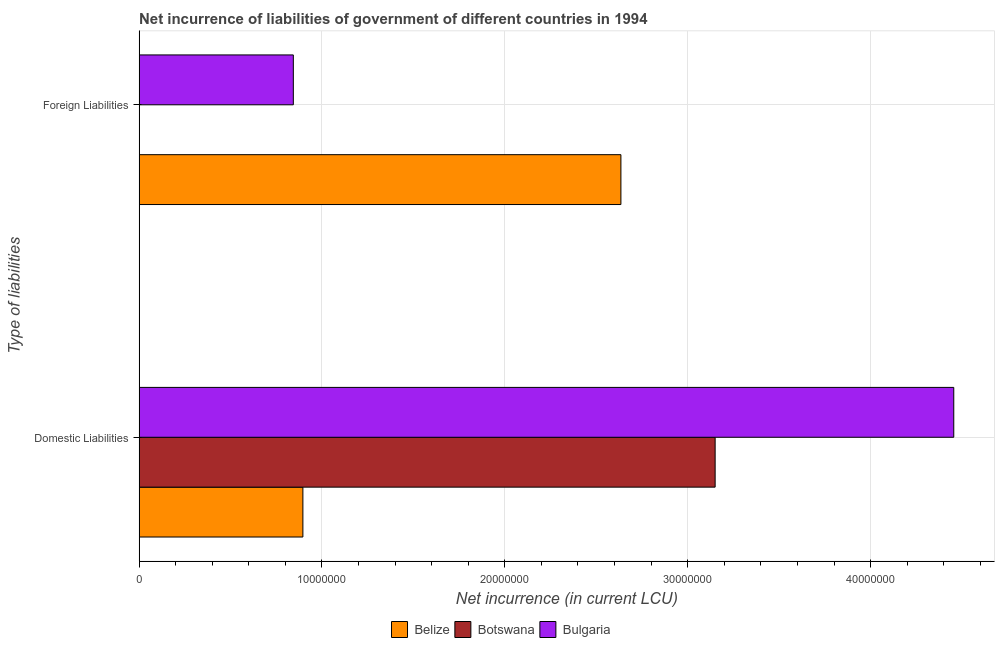How many different coloured bars are there?
Make the answer very short. 3. Are the number of bars per tick equal to the number of legend labels?
Your answer should be compact. No. How many bars are there on the 2nd tick from the bottom?
Your response must be concise. 2. What is the label of the 1st group of bars from the top?
Offer a very short reply. Foreign Liabilities. What is the net incurrence of domestic liabilities in Botswana?
Provide a succinct answer. 3.15e+07. Across all countries, what is the maximum net incurrence of domestic liabilities?
Ensure brevity in your answer.  4.45e+07. Across all countries, what is the minimum net incurrence of domestic liabilities?
Offer a very short reply. 8.96e+06. In which country was the net incurrence of foreign liabilities maximum?
Your answer should be compact. Belize. What is the total net incurrence of domestic liabilities in the graph?
Your answer should be compact. 8.50e+07. What is the difference between the net incurrence of domestic liabilities in Belize and that in Botswana?
Ensure brevity in your answer.  -2.25e+07. What is the difference between the net incurrence of foreign liabilities in Belize and the net incurrence of domestic liabilities in Bulgaria?
Provide a succinct answer. -1.82e+07. What is the average net incurrence of foreign liabilities per country?
Give a very brief answer. 1.16e+07. What is the difference between the net incurrence of domestic liabilities and net incurrence of foreign liabilities in Bulgaria?
Give a very brief answer. 3.61e+07. What is the ratio of the net incurrence of domestic liabilities in Bulgaria to that in Belize?
Offer a very short reply. 4.97. How many bars are there?
Your response must be concise. 5. Are all the bars in the graph horizontal?
Give a very brief answer. Yes. How many countries are there in the graph?
Offer a very short reply. 3. What is the difference between two consecutive major ticks on the X-axis?
Ensure brevity in your answer.  1.00e+07. Does the graph contain grids?
Give a very brief answer. Yes. How many legend labels are there?
Offer a very short reply. 3. What is the title of the graph?
Offer a terse response. Net incurrence of liabilities of government of different countries in 1994. Does "Chile" appear as one of the legend labels in the graph?
Your answer should be very brief. No. What is the label or title of the X-axis?
Ensure brevity in your answer.  Net incurrence (in current LCU). What is the label or title of the Y-axis?
Offer a very short reply. Type of liabilities. What is the Net incurrence (in current LCU) in Belize in Domestic Liabilities?
Your response must be concise. 8.96e+06. What is the Net incurrence (in current LCU) of Botswana in Domestic Liabilities?
Ensure brevity in your answer.  3.15e+07. What is the Net incurrence (in current LCU) in Bulgaria in Domestic Liabilities?
Offer a very short reply. 4.45e+07. What is the Net incurrence (in current LCU) of Belize in Foreign Liabilities?
Offer a very short reply. 2.63e+07. What is the Net incurrence (in current LCU) in Botswana in Foreign Liabilities?
Ensure brevity in your answer.  0. What is the Net incurrence (in current LCU) of Bulgaria in Foreign Liabilities?
Offer a very short reply. 8.43e+06. Across all Type of liabilities, what is the maximum Net incurrence (in current LCU) of Belize?
Provide a short and direct response. 2.63e+07. Across all Type of liabilities, what is the maximum Net incurrence (in current LCU) of Botswana?
Your response must be concise. 3.15e+07. Across all Type of liabilities, what is the maximum Net incurrence (in current LCU) in Bulgaria?
Provide a short and direct response. 4.45e+07. Across all Type of liabilities, what is the minimum Net incurrence (in current LCU) of Belize?
Your answer should be compact. 8.96e+06. Across all Type of liabilities, what is the minimum Net incurrence (in current LCU) of Bulgaria?
Make the answer very short. 8.43e+06. What is the total Net incurrence (in current LCU) of Belize in the graph?
Your response must be concise. 3.53e+07. What is the total Net incurrence (in current LCU) in Botswana in the graph?
Ensure brevity in your answer.  3.15e+07. What is the total Net incurrence (in current LCU) in Bulgaria in the graph?
Ensure brevity in your answer.  5.30e+07. What is the difference between the Net incurrence (in current LCU) in Belize in Domestic Liabilities and that in Foreign Liabilities?
Ensure brevity in your answer.  -1.74e+07. What is the difference between the Net incurrence (in current LCU) in Bulgaria in Domestic Liabilities and that in Foreign Liabilities?
Offer a terse response. 3.61e+07. What is the difference between the Net incurrence (in current LCU) in Belize in Domestic Liabilities and the Net incurrence (in current LCU) in Bulgaria in Foreign Liabilities?
Keep it short and to the point. 5.23e+05. What is the difference between the Net incurrence (in current LCU) in Botswana in Domestic Liabilities and the Net incurrence (in current LCU) in Bulgaria in Foreign Liabilities?
Ensure brevity in your answer.  2.31e+07. What is the average Net incurrence (in current LCU) of Belize per Type of liabilities?
Your response must be concise. 1.77e+07. What is the average Net incurrence (in current LCU) of Botswana per Type of liabilities?
Offer a very short reply. 1.58e+07. What is the average Net incurrence (in current LCU) of Bulgaria per Type of liabilities?
Offer a very short reply. 2.65e+07. What is the difference between the Net incurrence (in current LCU) of Belize and Net incurrence (in current LCU) of Botswana in Domestic Liabilities?
Keep it short and to the point. -2.25e+07. What is the difference between the Net incurrence (in current LCU) of Belize and Net incurrence (in current LCU) of Bulgaria in Domestic Liabilities?
Give a very brief answer. -3.56e+07. What is the difference between the Net incurrence (in current LCU) in Botswana and Net incurrence (in current LCU) in Bulgaria in Domestic Liabilities?
Give a very brief answer. -1.30e+07. What is the difference between the Net incurrence (in current LCU) of Belize and Net incurrence (in current LCU) of Bulgaria in Foreign Liabilities?
Keep it short and to the point. 1.79e+07. What is the ratio of the Net incurrence (in current LCU) of Belize in Domestic Liabilities to that in Foreign Liabilities?
Make the answer very short. 0.34. What is the ratio of the Net incurrence (in current LCU) in Bulgaria in Domestic Liabilities to that in Foreign Liabilities?
Provide a succinct answer. 5.28. What is the difference between the highest and the second highest Net incurrence (in current LCU) of Belize?
Ensure brevity in your answer.  1.74e+07. What is the difference between the highest and the second highest Net incurrence (in current LCU) in Bulgaria?
Make the answer very short. 3.61e+07. What is the difference between the highest and the lowest Net incurrence (in current LCU) in Belize?
Ensure brevity in your answer.  1.74e+07. What is the difference between the highest and the lowest Net incurrence (in current LCU) in Botswana?
Give a very brief answer. 3.15e+07. What is the difference between the highest and the lowest Net incurrence (in current LCU) in Bulgaria?
Your response must be concise. 3.61e+07. 